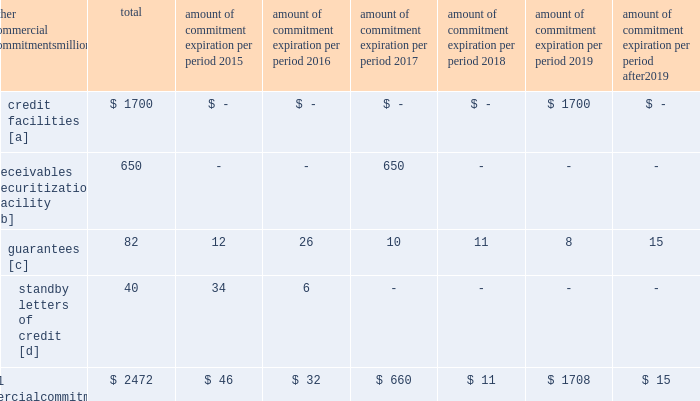Amount of commitment expiration per period other commercial commitments after millions total 2015 2016 2017 2018 2019 2019 .
[a] none of the credit facility was used as of december 31 , 2014 .
[b] $ 400 million of the receivables securitization facility was utilized as of december 31 , 2014 , which is accounted for as debt .
The full program matures in july 2017 .
[c] includes guaranteed obligations related to our equipment financings and affiliated operations .
[d] none of the letters of credit were drawn upon as of december 31 , 2014 .
Off-balance sheet arrangements guarantees 2013 at december 31 , 2014 , and 2013 , we were contingently liable for $ 82 million and $ 299 million in guarantees .
We have recorded liabilities of $ 0.3 million and $ 1 million for the fair value of these obligations as of december 31 , 2014 , and 2013 , respectively .
We entered into these contingent guarantees in the normal course of business , and they include guaranteed obligations related to our equipment financings and affiliated operations .
The final guarantee expires in 2022 .
We are not aware of any existing event of default that would require us to satisfy these guarantees .
We do not expect that these guarantees will have a material adverse effect on our consolidated financial condition , results of operations , or liquidity .
Other matters labor agreements 2013 approximately 85% ( 85 % ) of our 47201 full-time-equivalent employees are represented by 14 major rail unions .
On january 1 , 2015 , current labor agreements became subject to modification and we began the current round of negotiations with the unions .
Existing agreements remain in effect until new agreements are reached or the railway labor act 2019s procedures ( which include mediation , cooling-off periods , and the possibility of presidential emergency boards and congressional intervention ) are exhausted .
Contract negotiations historically continue for an extended period of time and we rarely experience work stoppages while negotiations are pending .
Inflation 2013 long periods of inflation significantly increase asset replacement costs for capital-intensive companies .
As a result , assuming that we replace all operating assets at current price levels , depreciation charges ( on an inflation-adjusted basis ) would be substantially greater than historically reported amounts .
Derivative financial instruments 2013 we may use derivative financial instruments in limited instances to assist in managing our overall exposure to fluctuations in interest rates and fuel prices .
We are not a party to leveraged derivatives and , by policy , do not use derivative financial instruments for speculative purposes .
Derivative financial instruments qualifying for hedge accounting must maintain a specified level of effectiveness between the hedging instrument and the item being hedged , both at inception and throughout the hedged period .
We formally document the nature and relationships between the hedging instruments and hedged items at inception , as well as our risk-management objectives , strategies for undertaking the various hedge transactions , and method of assessing hedge effectiveness .
Changes in the fair market value of derivative financial instruments that do not qualify for hedge accounting are charged to earnings .
We may use swaps , collars , futures , and/or forward contracts to mitigate the risk of adverse movements in interest rates and fuel prices ; however , the use of these derivative financial instruments may limit future benefits from favorable price movements .
Market and credit risk 2013 we address market risk related to derivative financial instruments by selecting instruments with value fluctuations that highly correlate with the underlying hedged item .
We manage credit risk related to derivative financial instruments , which is minimal , by requiring high credit standards for counterparties and periodic settlements .
At december 31 , 2014 and 2013 , we were not required to provide collateral , nor had we received collateral , relating to our hedging activities. .
What percentage of the total commercial commitments is credit facilities? 
Computations: (1700 / 2472)
Answer: 0.6877. 